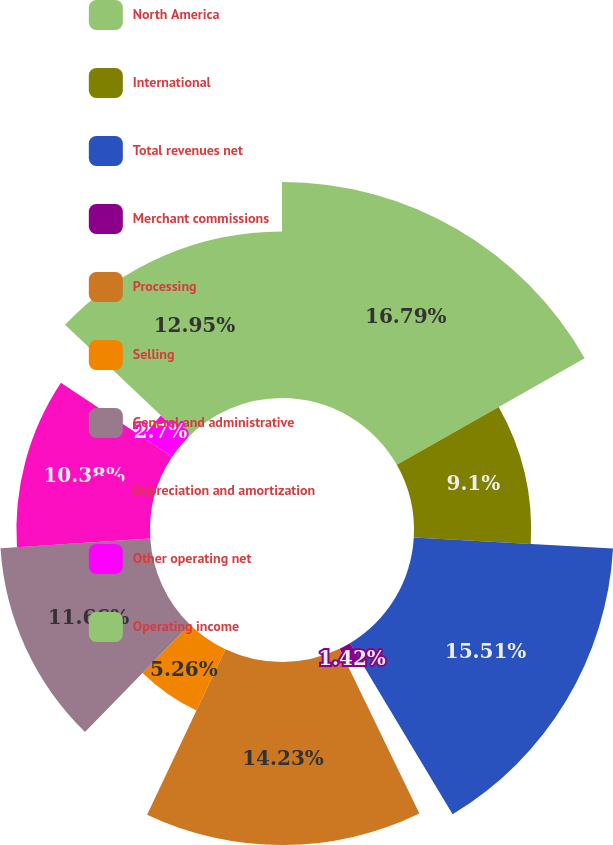Convert chart to OTSL. <chart><loc_0><loc_0><loc_500><loc_500><pie_chart><fcel>North America<fcel>International<fcel>Total revenues net<fcel>Merchant commissions<fcel>Processing<fcel>Selling<fcel>General and administrative<fcel>Depreciation and amortization<fcel>Other operating net<fcel>Operating income<nl><fcel>16.78%<fcel>9.1%<fcel>15.5%<fcel>1.42%<fcel>14.22%<fcel>5.26%<fcel>11.66%<fcel>10.38%<fcel>2.7%<fcel>12.94%<nl></chart> 